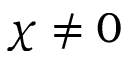Convert formula to latex. <formula><loc_0><loc_0><loc_500><loc_500>\chi \neq 0</formula> 